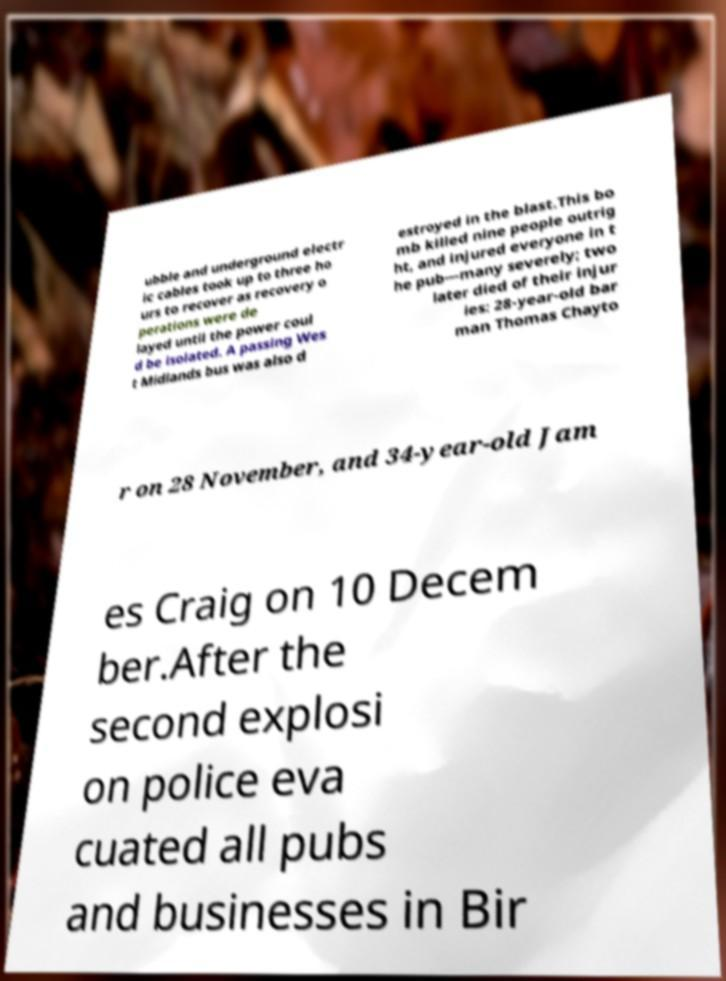Could you extract and type out the text from this image? ubble and underground electr ic cables took up to three ho urs to recover as recovery o perations were de layed until the power coul d be isolated. A passing Wes t Midlands bus was also d estroyed in the blast.This bo mb killed nine people outrig ht, and injured everyone in t he pub—many severely; two later died of their injur ies: 28-year-old bar man Thomas Chayto r on 28 November, and 34-year-old Jam es Craig on 10 Decem ber.After the second explosi on police eva cuated all pubs and businesses in Bir 